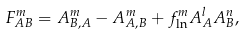<formula> <loc_0><loc_0><loc_500><loc_500>F ^ { m } _ { A B } = A ^ { m } _ { B , A } - A ^ { m } _ { A , B } + f ^ { m } _ { \ln } A ^ { l } _ { A } A ^ { n } _ { B } ,</formula> 